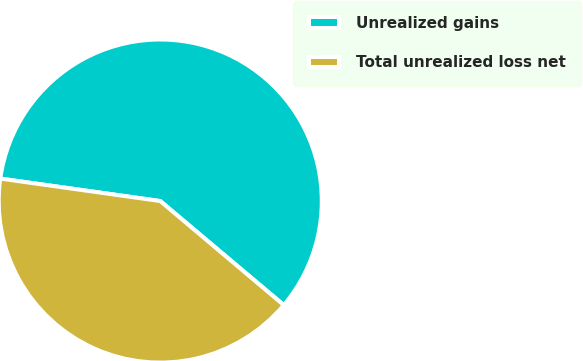<chart> <loc_0><loc_0><loc_500><loc_500><pie_chart><fcel>Unrealized gains<fcel>Total unrealized loss net<nl><fcel>58.92%<fcel>41.08%<nl></chart> 